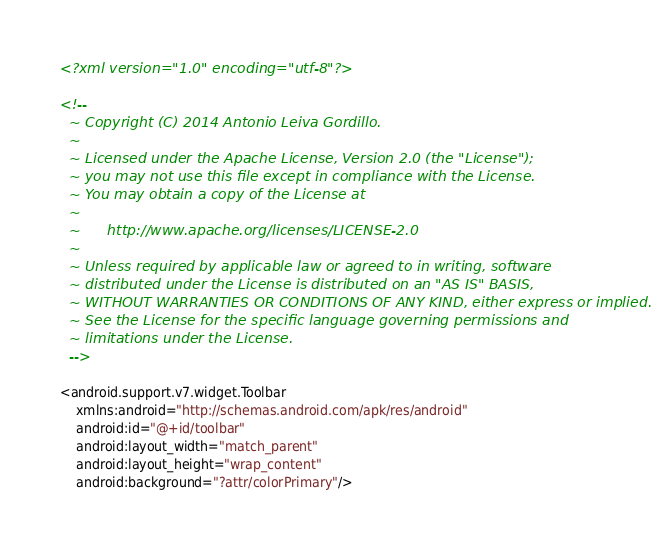Convert code to text. <code><loc_0><loc_0><loc_500><loc_500><_XML_><?xml version="1.0" encoding="utf-8"?>

<!--
  ~ Copyright (C) 2014 Antonio Leiva Gordillo.
  ~
  ~ Licensed under the Apache License, Version 2.0 (the "License");
  ~ you may not use this file except in compliance with the License.
  ~ You may obtain a copy of the License at
  ~
  ~      http://www.apache.org/licenses/LICENSE-2.0
  ~
  ~ Unless required by applicable law or agreed to in writing, software
  ~ distributed under the License is distributed on an "AS IS" BASIS,
  ~ WITHOUT WARRANTIES OR CONDITIONS OF ANY KIND, either express or implied.
  ~ See the License for the specific language governing permissions and
  ~ limitations under the License.
  -->

<android.support.v7.widget.Toolbar
    xmlns:android="http://schemas.android.com/apk/res/android"
    android:id="@+id/toolbar"
    android:layout_width="match_parent"
    android:layout_height="wrap_content"
    android:background="?attr/colorPrimary"/></code> 